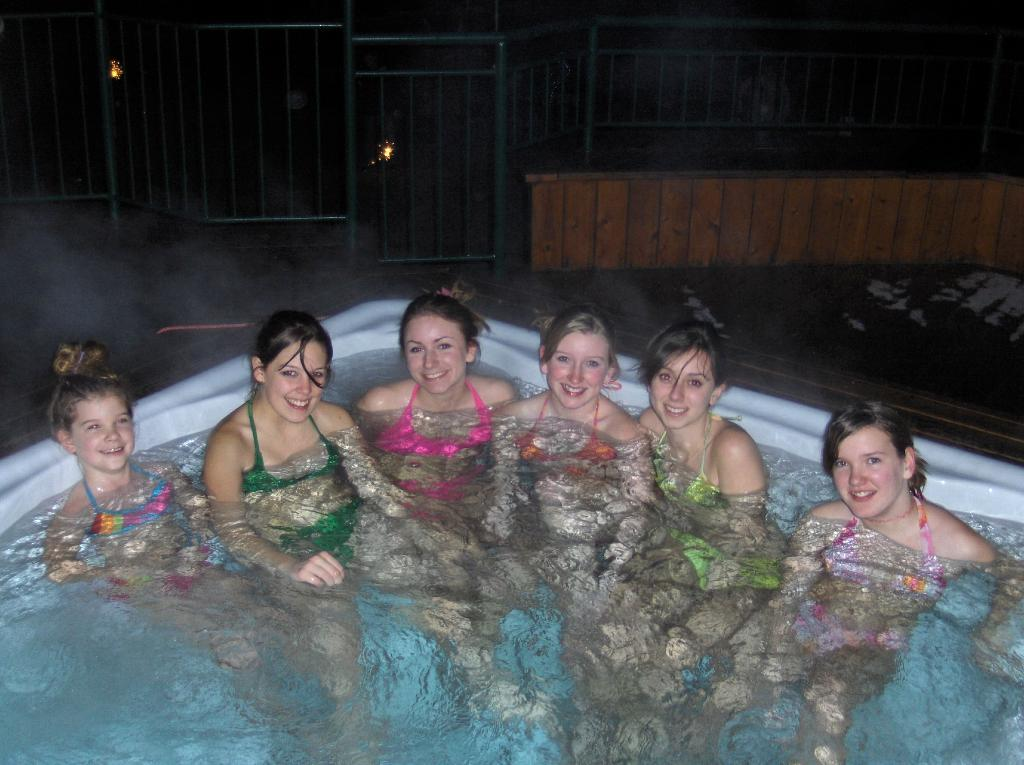What are the people in the image doing? The people in the image are in the water. What can be seen in the background of the image? There is a fence in the background of the image. What type of songs can be heard being sung by the people in the water? There is no indication in the image that the people are singing songs, so it cannot be determined from the picture. 